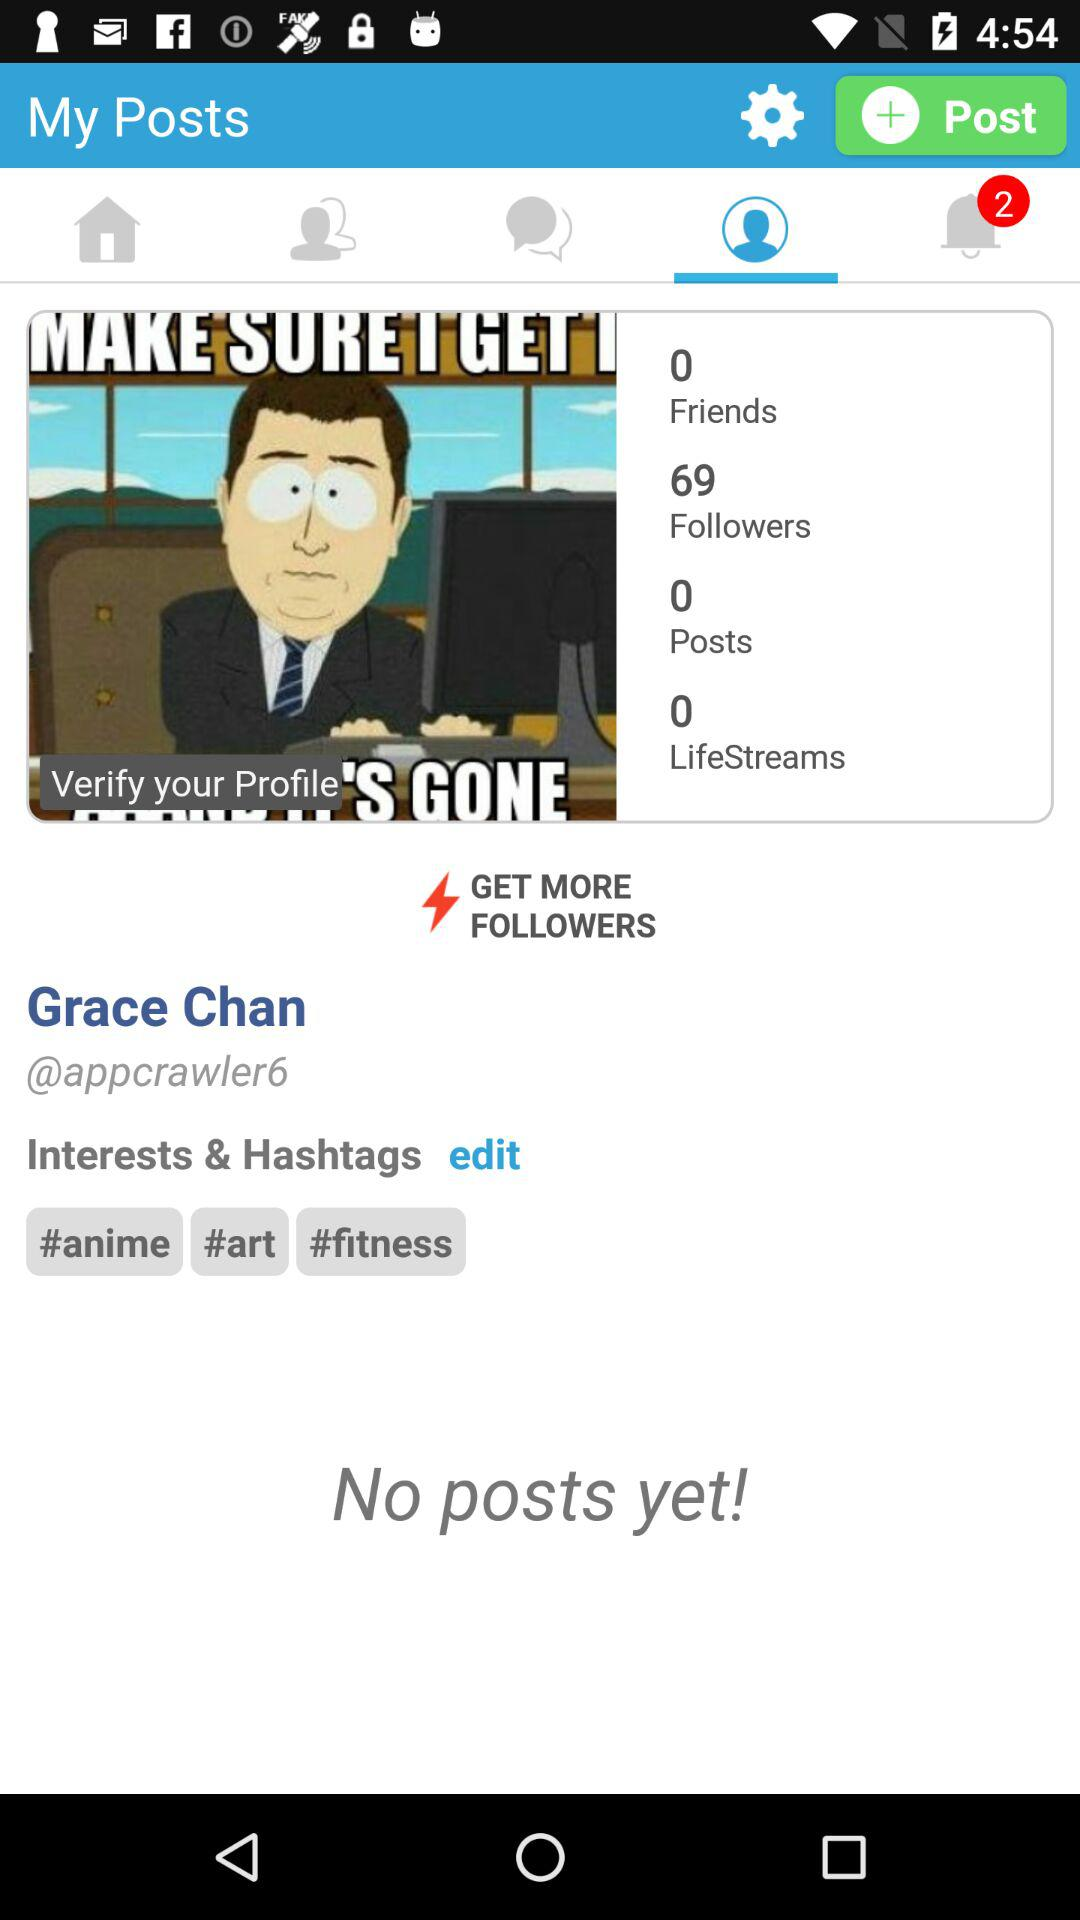How many friends are there? There are 0 friends. 